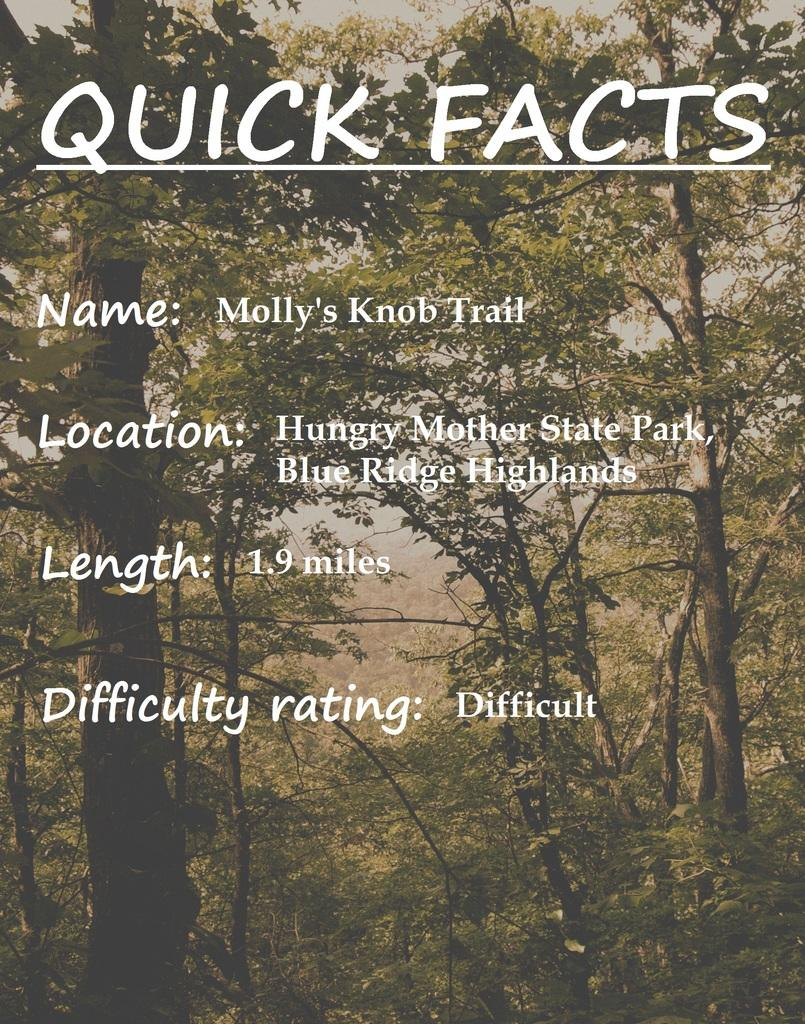<image>
Present a compact description of the photo's key features. a poster with QUICK Facts about Molly's Knob Trail 